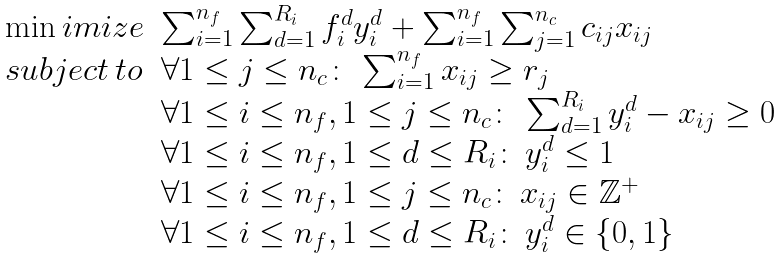Convert formula to latex. <formula><loc_0><loc_0><loc_500><loc_500>\begin{array} { l l c } \min i m i z e & \sum _ { i = 1 } ^ { n _ { f } } \sum _ { d = 1 } ^ { R _ { i } } f _ { i } ^ { d } y _ { i } ^ { d } + \sum _ { i = 1 } ^ { n _ { f } } \sum _ { j = 1 } ^ { n _ { c } } c _ { i j } x _ { i j } \\ s u b j e c t \, t o & \forall 1 \leq j \leq n _ { c } \colon \, \sum _ { i = 1 } ^ { n _ { f } } x _ { i j } \geq r _ { j } \\ & \forall 1 \leq i \leq n _ { f } , 1 \leq j \leq n _ { c } \colon \, \sum _ { d = 1 } ^ { R _ { i } } y _ { i } ^ { d } - x _ { i j } \geq 0 \\ & \forall 1 \leq i \leq n _ { f } , 1 \leq d \leq R _ { i } \colon \, y _ { i } ^ { d } \leq 1 \\ & \forall 1 \leq i \leq n _ { f } , 1 \leq j \leq n _ { c } \colon \, x _ { i j } \in \mathbb { Z } ^ { + } \\ & \forall 1 \leq i \leq n _ { f } , 1 \leq d \leq R _ { i } \colon \, y _ { i } ^ { d } \in \left \{ 0 , 1 \right \} \end{array}</formula> 